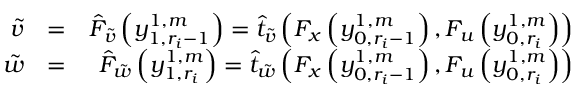<formula> <loc_0><loc_0><loc_500><loc_500>\begin{array} { r l r } { \tilde { v } } & { = } & { \hat { F } _ { \tilde { v } } \left ( y _ { 1 , r _ { i } - 1 } ^ { 1 , m } \right ) = \hat { t } _ { \tilde { v } } \left ( F _ { x } \left ( y _ { 0 , r _ { i } - 1 } ^ { 1 , m } \right ) , F _ { u } \left ( y _ { 0 , r _ { i } } ^ { 1 , m } \right ) \right ) } \\ { \tilde { w } } & { = } & { \hat { F } _ { \tilde { w } } \left ( y _ { 1 , r _ { i } } ^ { 1 , m } \right ) = \hat { t } _ { \tilde { w } } \left ( F _ { x } \left ( y _ { 0 , r _ { i } - 1 } ^ { 1 , m } \right ) , F _ { u } \left ( y _ { 0 , r _ { i } } ^ { 1 , m } \right ) \right ) } \end{array}</formula> 